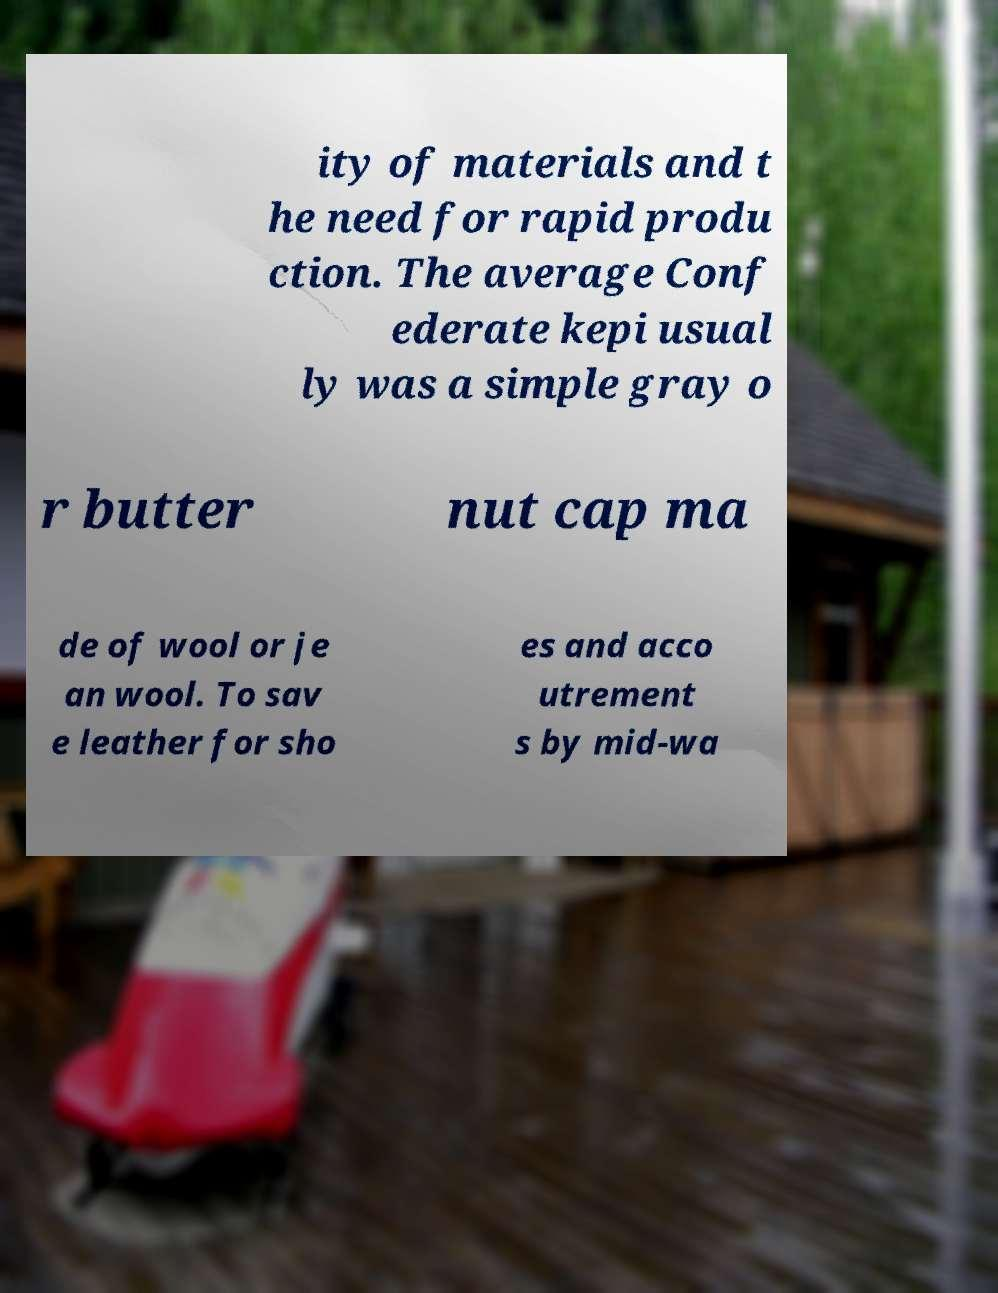Can you read and provide the text displayed in the image?This photo seems to have some interesting text. Can you extract and type it out for me? ity of materials and t he need for rapid produ ction. The average Conf ederate kepi usual ly was a simple gray o r butter nut cap ma de of wool or je an wool. To sav e leather for sho es and acco utrement s by mid-wa 